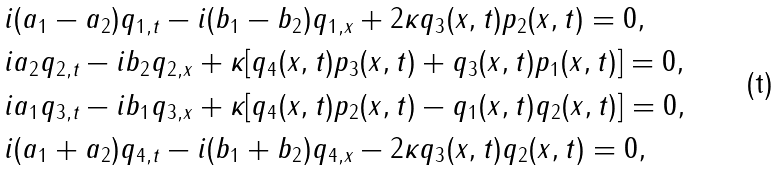<formula> <loc_0><loc_0><loc_500><loc_500>& i ( a _ { 1 } - a _ { 2 } ) q _ { 1 , t } - i ( b _ { 1 } - b _ { 2 } ) q _ { 1 , x } + 2 \kappa q _ { 3 } ( x , t ) p _ { 2 } ( x , t ) = 0 , \\ & i a _ { 2 } q _ { 2 , t } - i b _ { 2 } q _ { 2 , x } + \kappa [ q _ { 4 } ( x , t ) p _ { 3 } ( x , t ) + q _ { 3 } ( x , t ) p _ { 1 } ( x , t ) ] = 0 , \\ & i a _ { 1 } q _ { 3 , t } - i b _ { 1 } q _ { 3 , x } + \kappa [ q _ { 4 } ( x , t ) p _ { 2 } ( x , t ) - q _ { 1 } ( x , t ) q _ { 2 } ( x , t ) ] = 0 , \\ & i ( a _ { 1 } + a _ { 2 } ) q _ { 4 , t } - i ( b _ { 1 } + b _ { 2 } ) q _ { 4 , x } - 2 \kappa q _ { 3 } ( x , t ) q _ { 2 } ( x , t ) = 0 ,</formula> 